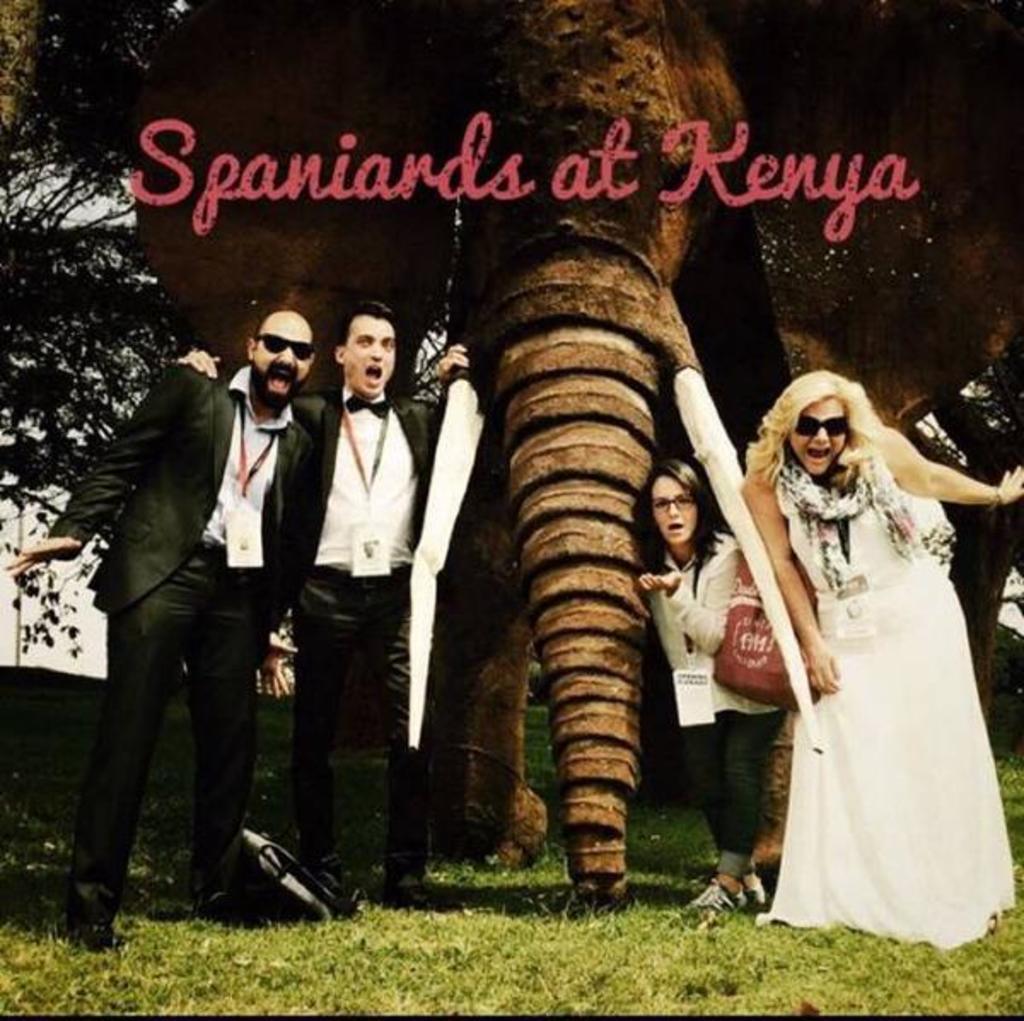How many people are standing in the image? There are four people standing in the image, two men and two women. What are the women doing in the image? The two women are standing and smiling in the grass. What objects can be seen in the image besides the people? There is a tree and a bag visible in the image. Can you describe the background of the image? There is a tree visible in the background of the image. What type of cream can be seen on the kitten in the image? There is no kitten present in the image, and therefore no cream can be seen on it. What is the air quality like in the image? The provided facts do not give any information about the air quality in the image. 